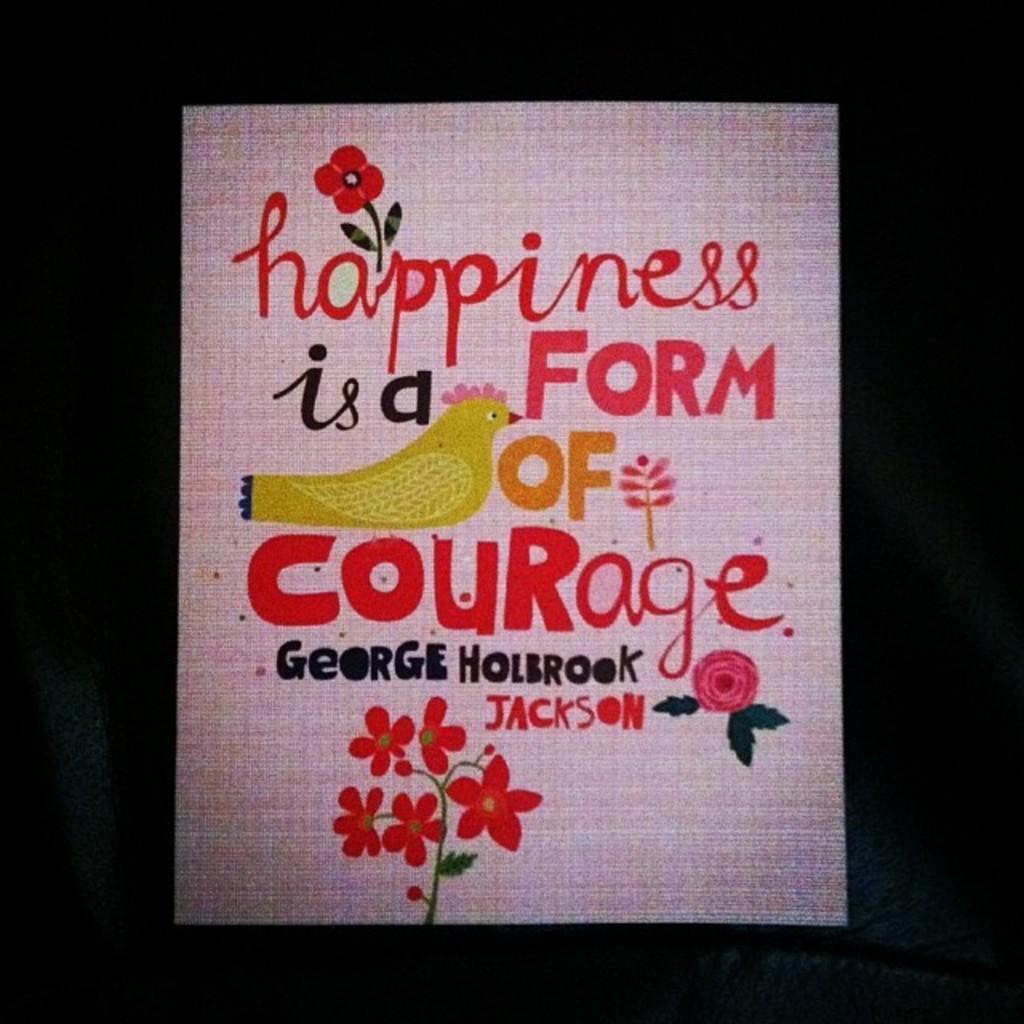In one or two sentences, can you explain what this image depicts? In this image there is a poster on which we can see there is some text and a drawing of flowers and bird. 